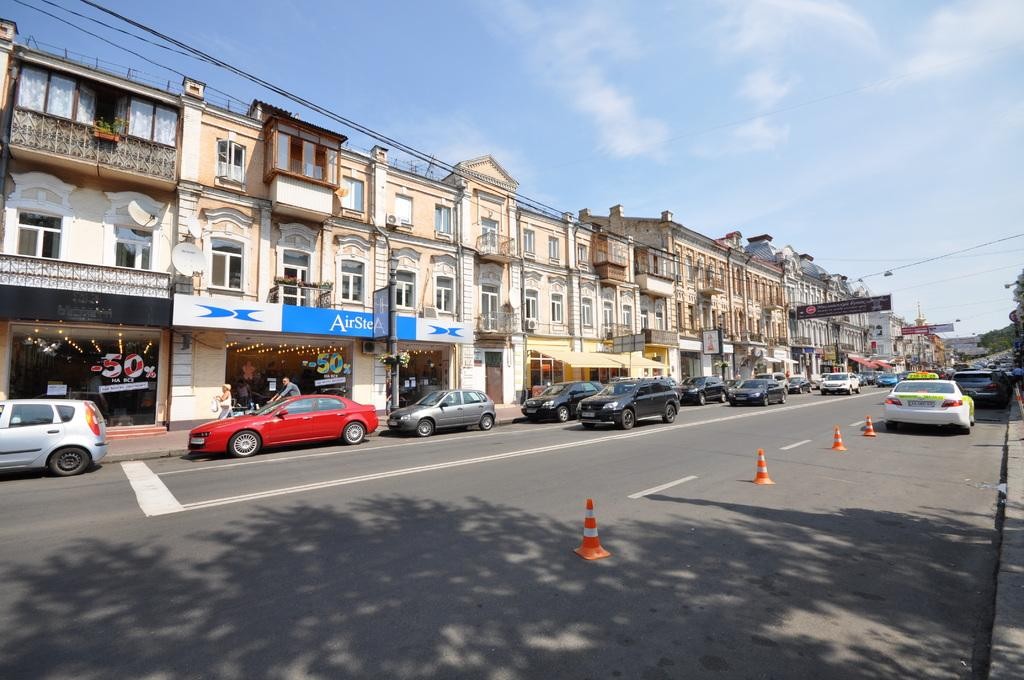What is happening on the road in the image? There are cars on the road in the image, and they are in traffic. What can be seen in the background of the image? There are buildings and the sky visible in the background of the image. What is the condition of the sky in the image? Clouds are present in the sky in the image. What type of plants can be seen exchanging information through a button in the image? There are no plants or buttons present in the image. 